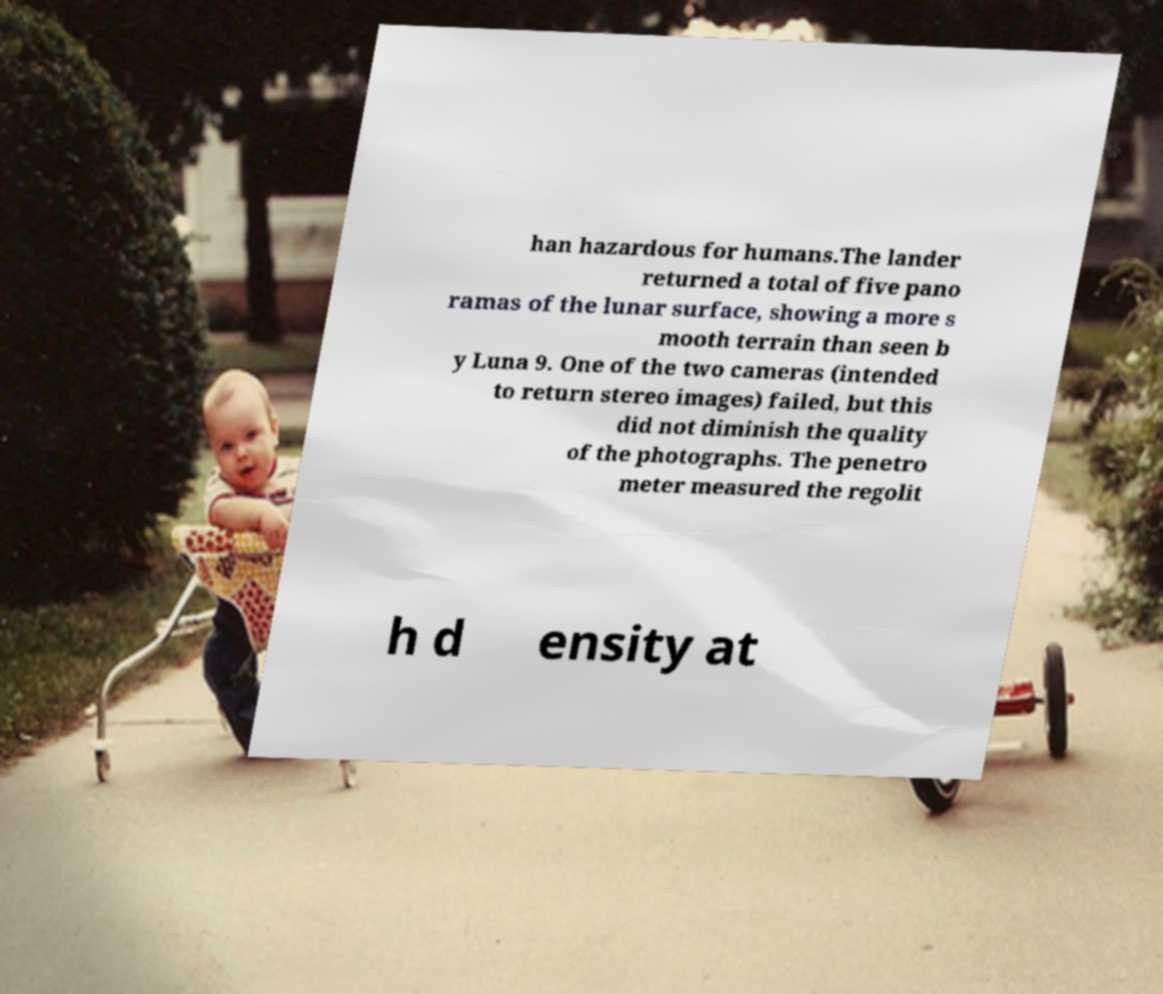What messages or text are displayed in this image? I need them in a readable, typed format. han hazardous for humans.The lander returned a total of five pano ramas of the lunar surface, showing a more s mooth terrain than seen b y Luna 9. One of the two cameras (intended to return stereo images) failed, but this did not diminish the quality of the photographs. The penetro meter measured the regolit h d ensity at 